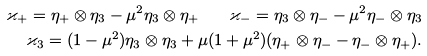Convert formula to latex. <formula><loc_0><loc_0><loc_500><loc_500>\varkappa _ { + } = \eta _ { + } \otimes \eta _ { 3 } - \mu ^ { 2 } \eta _ { 3 } \otimes \eta _ { + } \quad \varkappa _ { - } = \eta _ { 3 } \otimes \eta _ { - } - \mu ^ { 2 } \eta _ { - } \otimes \eta _ { 3 } \\ \varkappa _ { 3 } = ( 1 - \mu ^ { 2 } ) \eta _ { 3 } \otimes \eta _ { 3 } + \mu ( 1 + \mu ^ { 2 } ) ( \eta _ { + } \otimes \eta _ { - } - \eta _ { - } \otimes \eta _ { + } ) .</formula> 